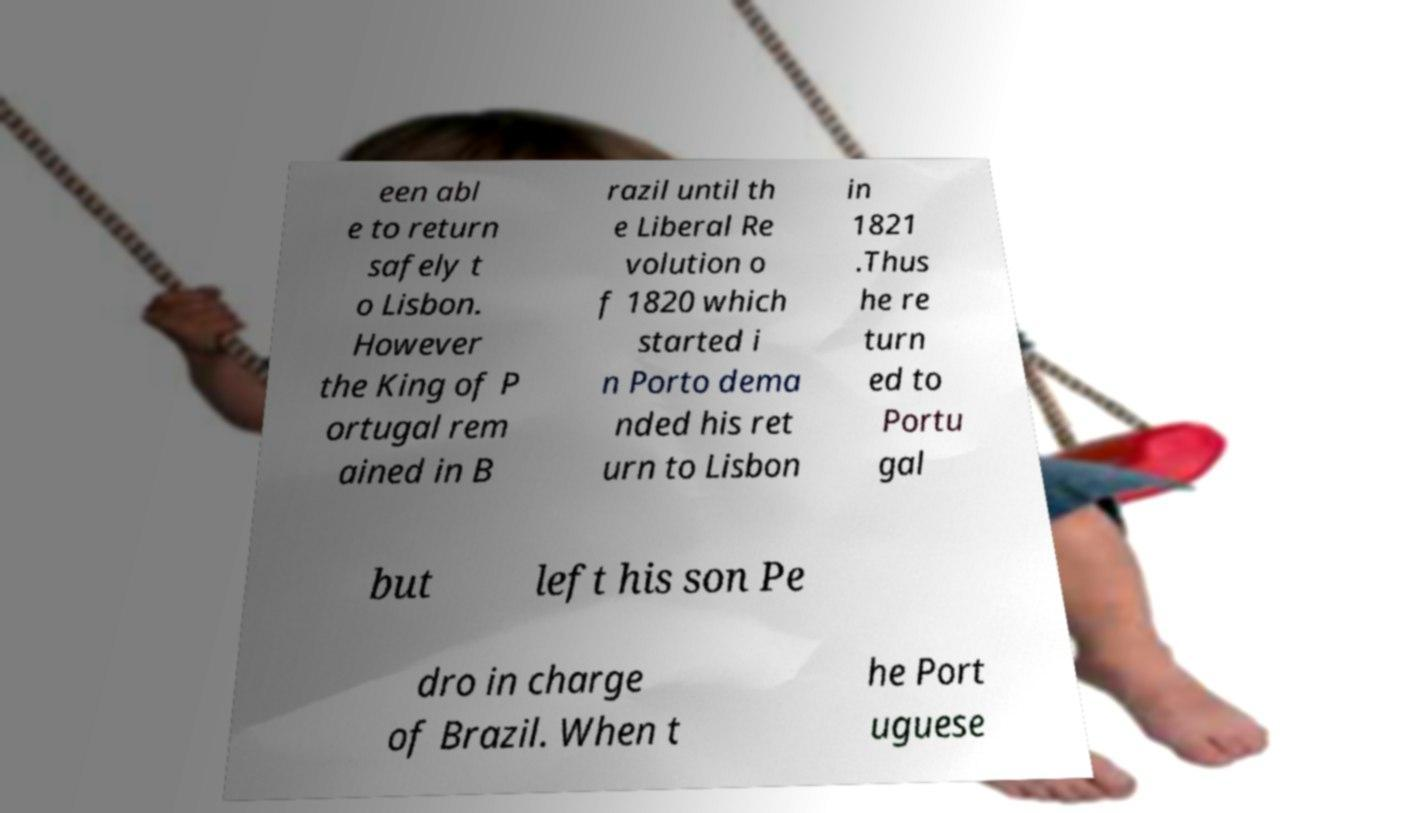What messages or text are displayed in this image? I need them in a readable, typed format. een abl e to return safely t o Lisbon. However the King of P ortugal rem ained in B razil until th e Liberal Re volution o f 1820 which started i n Porto dema nded his ret urn to Lisbon in 1821 .Thus he re turn ed to Portu gal but left his son Pe dro in charge of Brazil. When t he Port uguese 